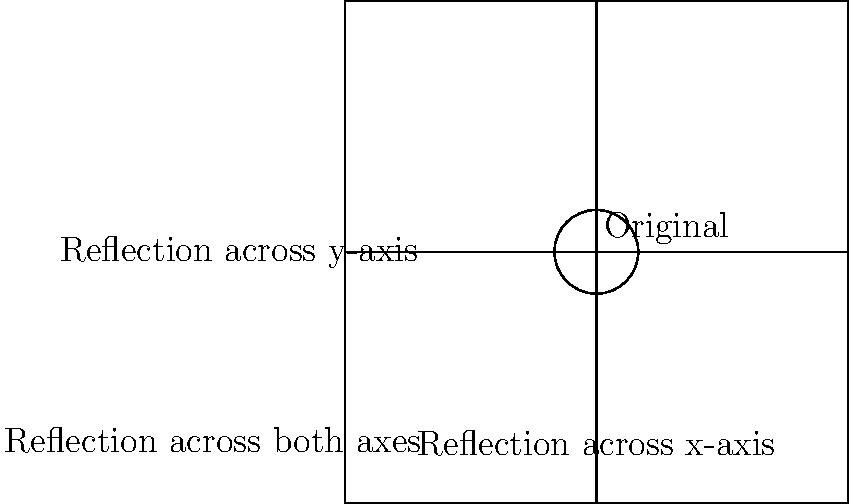In the context of online dating profile optimization, a tech executive decides to experiment with profile picture transformations. The original circular profile picture is centered at (1,1) with a radius of 0.5 units. If the picture is reflected across both the x-axis and y-axis, what will be the coordinates of the center of the transformed profile picture? Let's approach this step-by-step:

1) The original profile picture is centered at (1,1).

2) Reflection across the y-axis:
   - The x-coordinate changes sign, while the y-coordinate remains the same.
   - (1,1) becomes (-1,1)

3) Reflection across the x-axis:
   - The y-coordinate changes sign, while the x-coordinate remains the same.
   - (1,1) becomes (1,-1)

4) Reflection across both axes:
   - Both x and y coordinates change signs.
   - (1,1) becomes (-1,-1)

Therefore, after reflecting across both axes, the center of the profile picture moves from (1,1) to (-1,-1).

This transformation demonstrates how the same profile picture can be viewed from different perspectives, potentially appealing to a broader audience in the online dating world.
Answer: (-1,-1) 